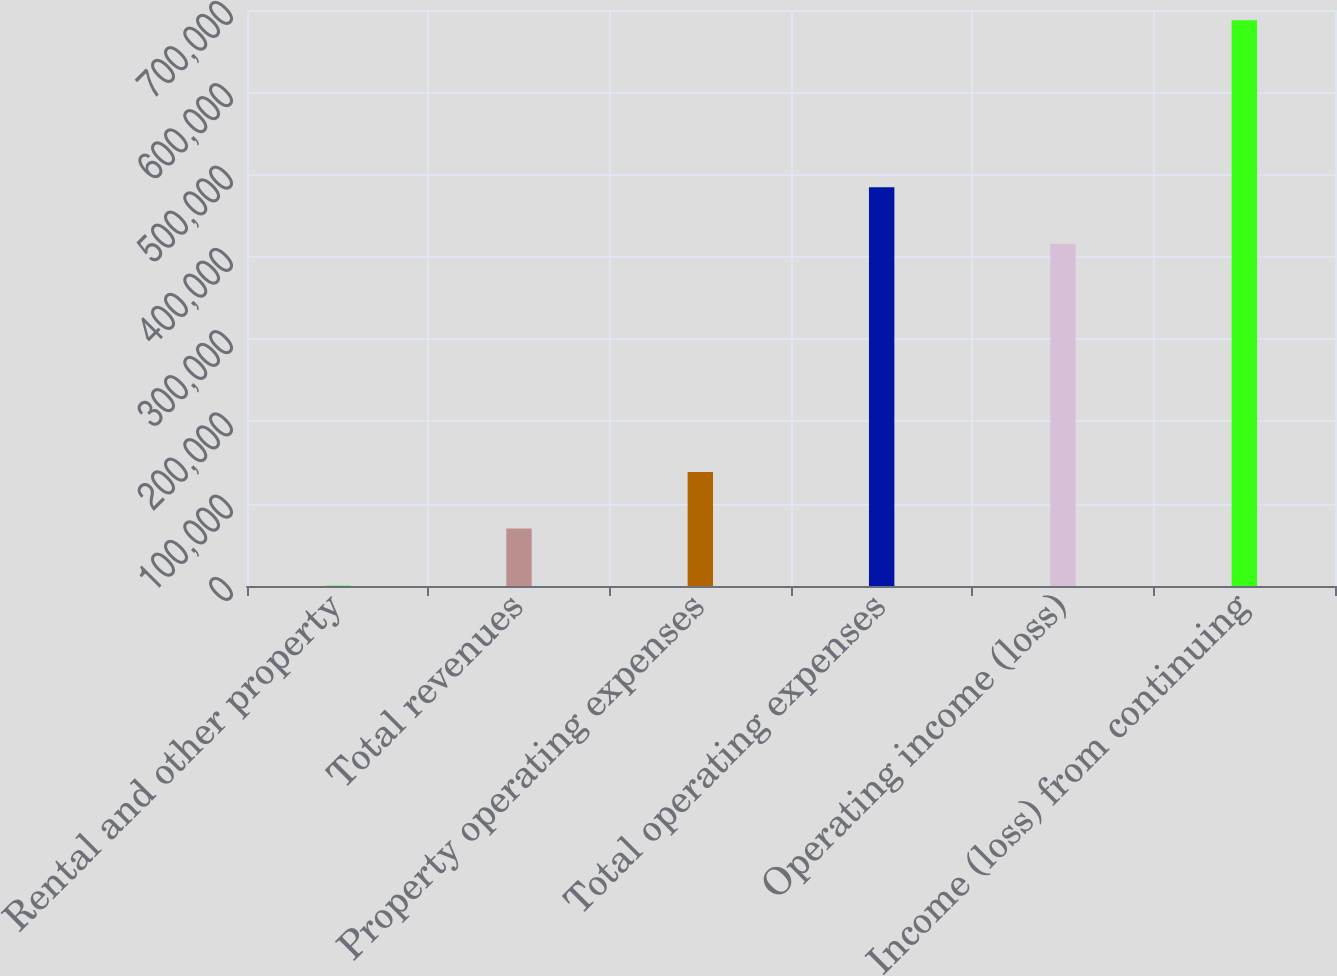Convert chart. <chart><loc_0><loc_0><loc_500><loc_500><bar_chart><fcel>Rental and other property<fcel>Total revenues<fcel>Property operating expenses<fcel>Total operating expenses<fcel>Operating income (loss)<fcel>Income (loss) from continuing<nl><fcel>1194<fcel>69827.8<fcel>138462<fcel>484638<fcel>416004<fcel>687532<nl></chart> 